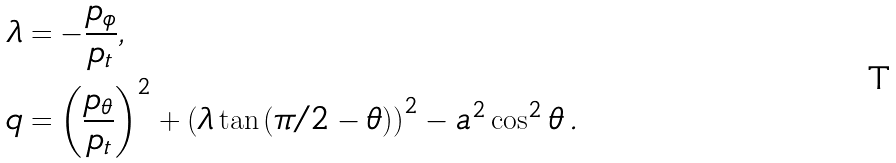<formula> <loc_0><loc_0><loc_500><loc_500>\lambda & = - \frac { p _ { \phi } } { p _ { t } } , \, \\ q & = \left ( \frac { p _ { \theta } } { p _ { t } } \right ) ^ { 2 } + \left ( \lambda \tan \left ( \pi / 2 - \theta \right ) \right ) ^ { 2 } - a ^ { 2 } \cos ^ { 2 } \theta \, .</formula> 